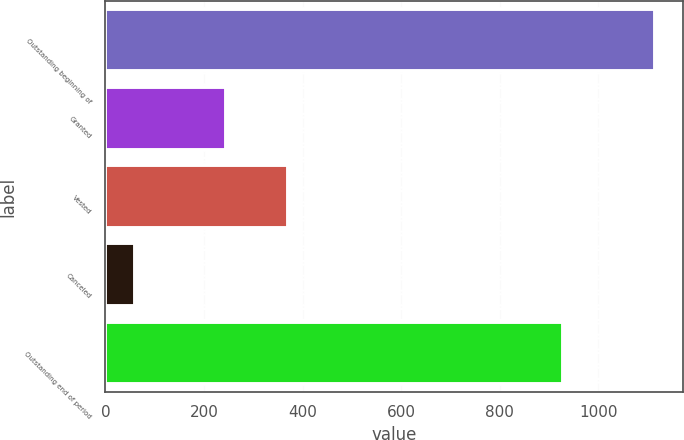Convert chart to OTSL. <chart><loc_0><loc_0><loc_500><loc_500><bar_chart><fcel>Outstanding beginning of<fcel>Granted<fcel>Vested<fcel>Canceled<fcel>Outstanding end of period<nl><fcel>1115<fcel>244<fcel>370<fcel>61<fcel>928<nl></chart> 